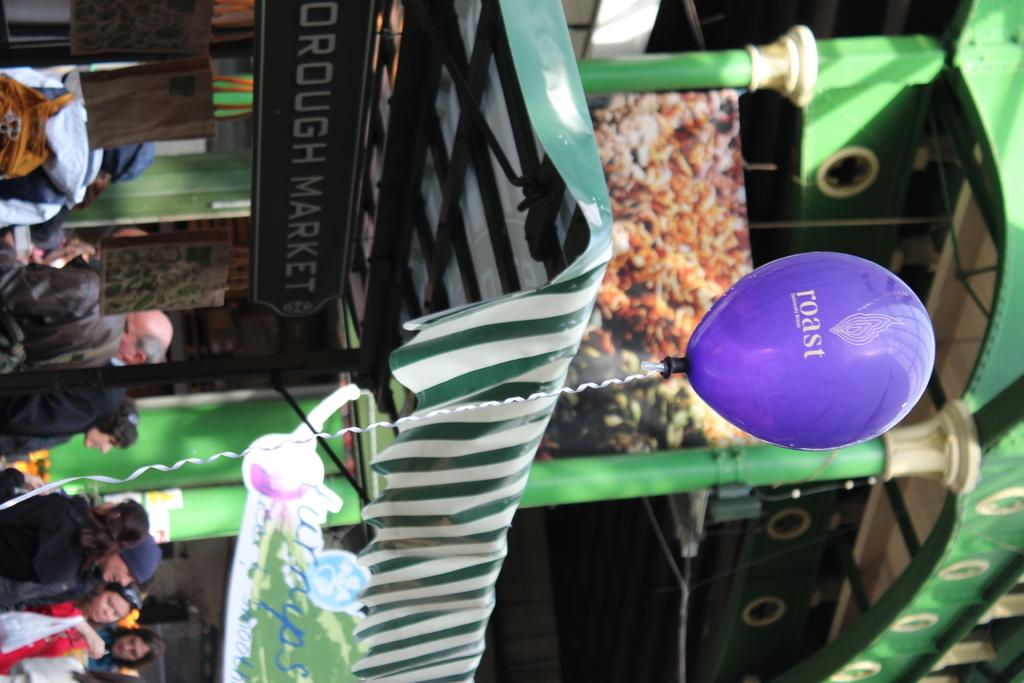Who can be seen in the image? There are people in the image. Where are the people located? The people are standing in a market. What can be seen in front of the market? There is a balloon with a rope in front of the market. What type of tramp is being used by the committee in the image? There is no tramp or committee present in the image. Can you tell me how much blood is visible on the people in the image? There is no blood visible on the people in the image. 